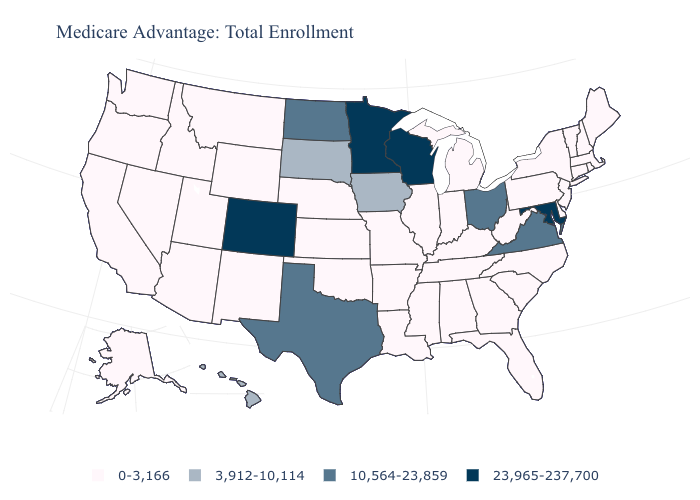What is the value of Maine?
Be succinct. 0-3,166. What is the value of Illinois?
Short answer required. 0-3,166. Among the states that border Georgia , which have the lowest value?
Give a very brief answer. Alabama, Florida, North Carolina, South Carolina, Tennessee. Among the states that border Nevada , which have the highest value?
Be succinct. Arizona, California, Idaho, Oregon, Utah. What is the value of Florida?
Be succinct. 0-3,166. Does the map have missing data?
Quick response, please. No. What is the highest value in states that border New Mexico?
Concise answer only. 23,965-237,700. Which states have the lowest value in the MidWest?
Short answer required. Illinois, Indiana, Kansas, Michigan, Missouri, Nebraska. What is the value of Wyoming?
Short answer required. 0-3,166. What is the lowest value in the USA?
Quick response, please. 0-3,166. What is the lowest value in states that border Virginia?
Concise answer only. 0-3,166. What is the value of Nevada?
Quick response, please. 0-3,166. Which states have the lowest value in the MidWest?
Keep it brief. Illinois, Indiana, Kansas, Michigan, Missouri, Nebraska. What is the value of Wyoming?
Quick response, please. 0-3,166. 